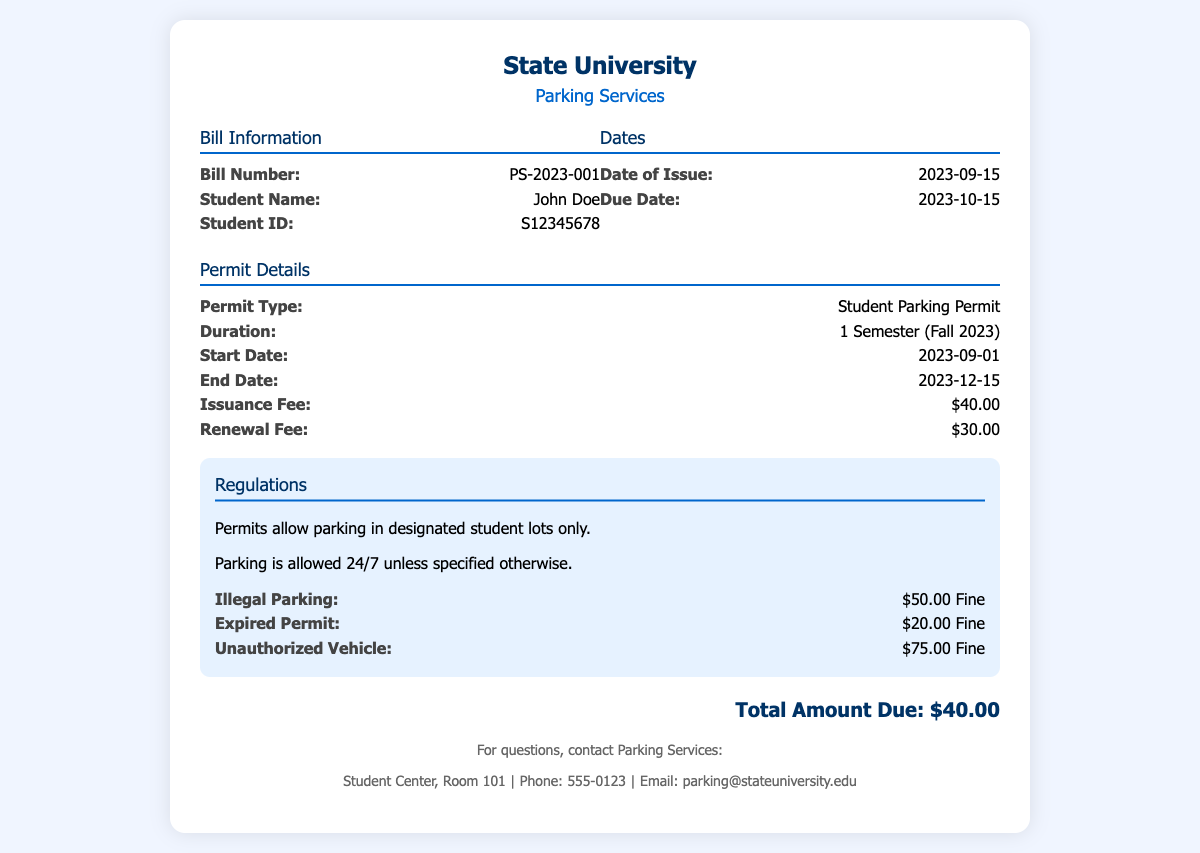What is the permit type? The permit type is mentioned in the document as "Student Parking Permit."
Answer: Student Parking Permit What is the issuance fee? The issuance fee is provided in the details section of the document, which states the fee amount.
Answer: $40.00 What is the due date? The due date is highlighted in the bill information section, indicating when the payment is due.
Answer: 2023-10-15 What is the fine for illegal parking? The document specifies the fine amount for illegal parking as part of the regulations section.
Answer: $50.00 Fine What is the duration of the permit? The duration of the permit is indicated in the permit details, specifying the duration of validity.
Answer: 1 Semester (Fall 2023) What is the total amount due? The total amount due is provided clearly at the end of the document, summarizing the fee.
Answer: $40.00 What date does the parking permit start? The start date of the parking permit is clearly mentioned in the permit details section.
Answer: 2023-09-01 What is the renewal fee? The renewal fee is listed in the permit details, indicating the cost for renewing the permit.
Answer: $30.00 What is the fine for an expired permit? The fine for an expired permit is specified in the regulations section of the document.
Answer: $20.00 Fine 